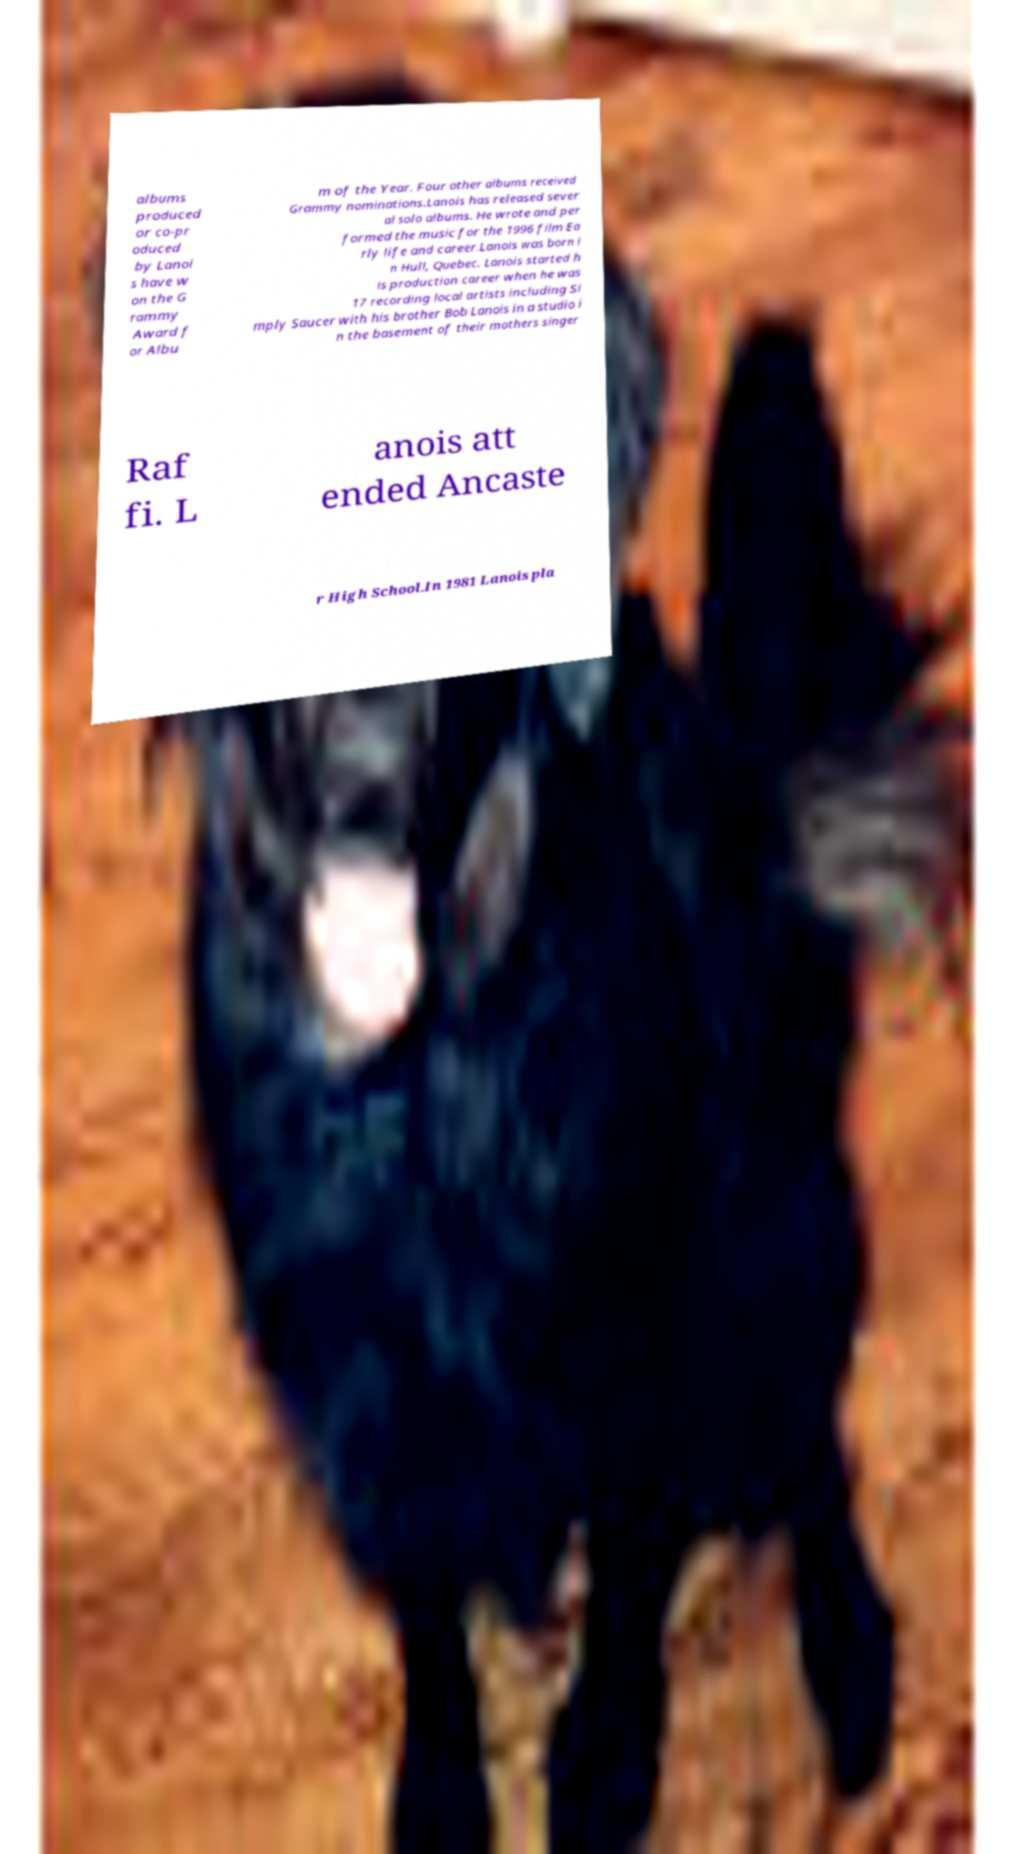Could you extract and type out the text from this image? albums produced or co-pr oduced by Lanoi s have w on the G rammy Award f or Albu m of the Year. Four other albums received Grammy nominations.Lanois has released sever al solo albums. He wrote and per formed the music for the 1996 film Ea rly life and career.Lanois was born i n Hull, Quebec. Lanois started h is production career when he was 17 recording local artists including Si mply Saucer with his brother Bob Lanois in a studio i n the basement of their mothers singer Raf fi. L anois att ended Ancaste r High School.In 1981 Lanois pla 